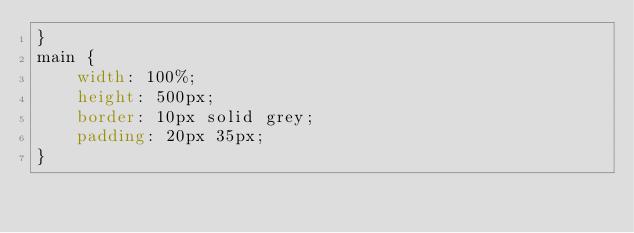Convert code to text. <code><loc_0><loc_0><loc_500><loc_500><_CSS_>}
main {
    width: 100%;
    height: 500px;
    border: 10px solid grey;
    padding: 20px 35px;
}</code> 